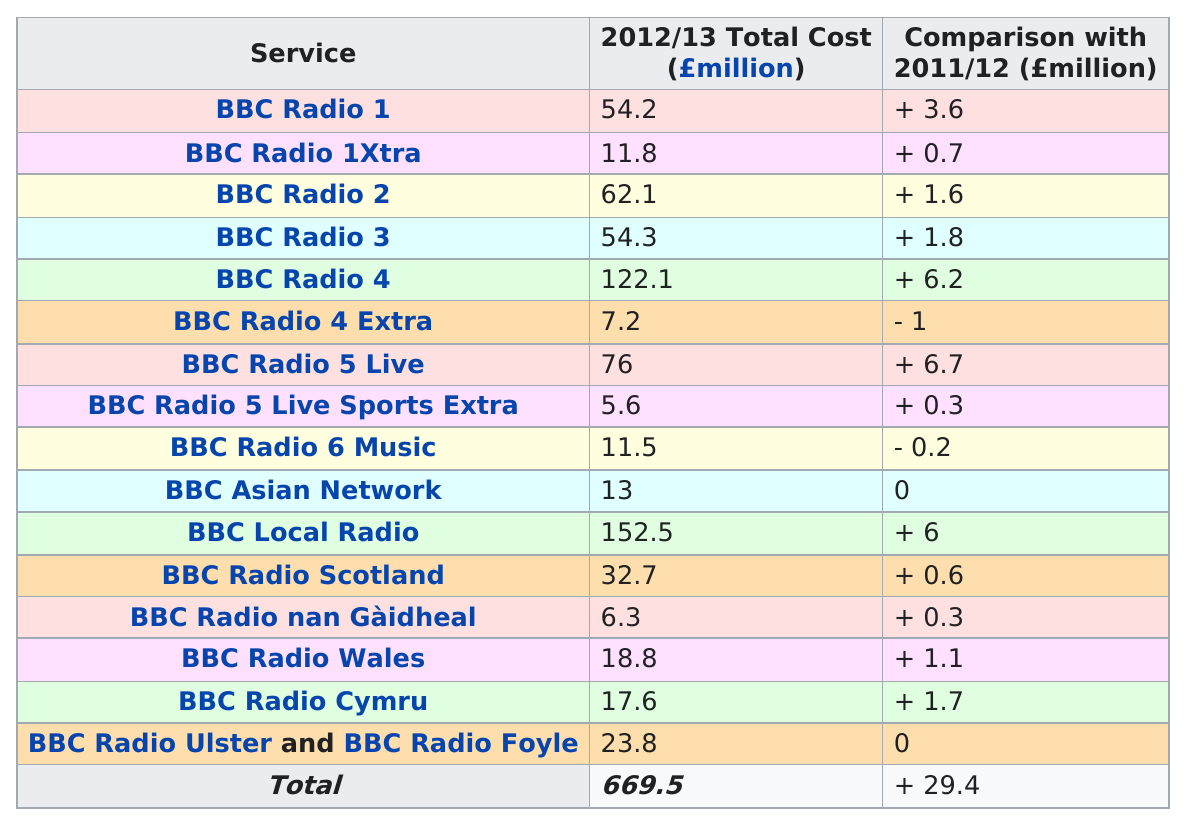Give some essential details in this illustration. In 2012/13, BBC Local Radio was the station that cost the most to run among all the BBC stations. 